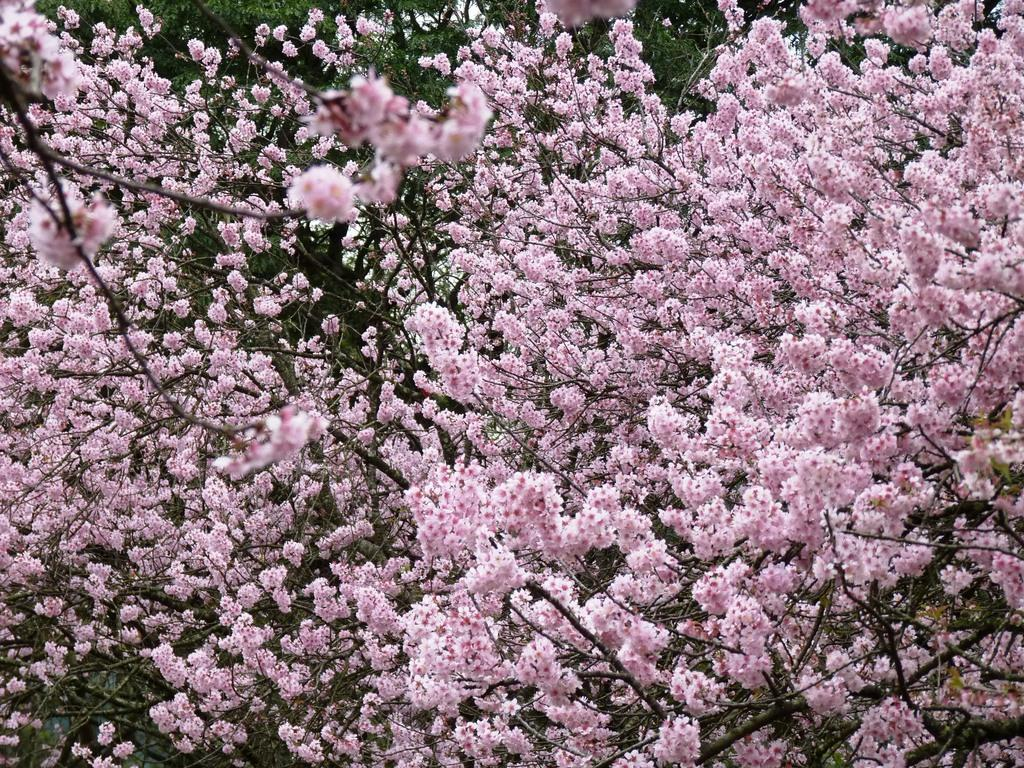What is the main subject of the image? The main subject of the image is a blossom of flowers. Can you describe the flowers in the blossom? Unfortunately, the facts provided do not give specific details about the flowers in the blossom. What might be the significance of the blossom in the image? The significance of the blossom in the image is not clear from the provided facts. What is the income of the person who ordered the flowers in the image? There is no person ordering flowers in the image, and therefore no income to discuss. 